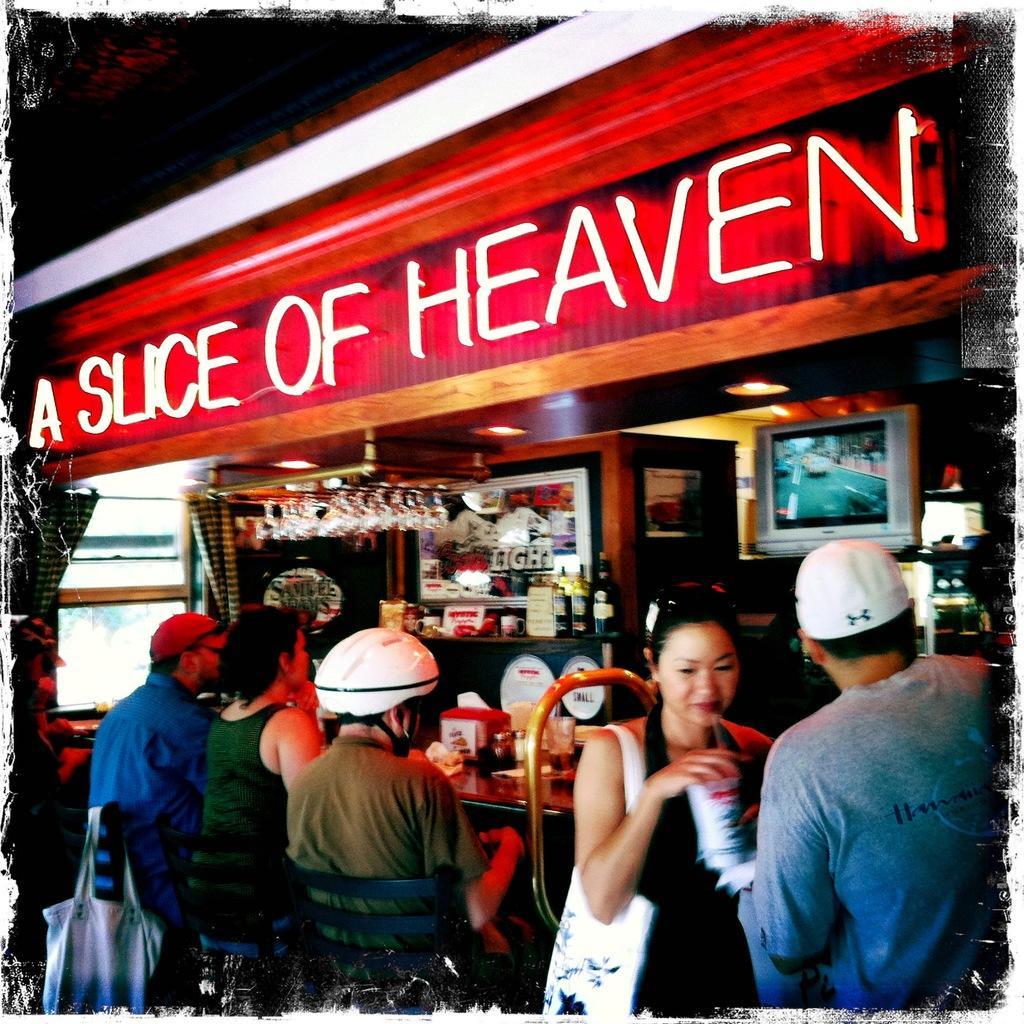Please provide a concise description of this image. In this image we can see many people. One person is wearing helmet. Two are wearing caps. One lady is holding a bag and a glass. And few are sitting on chairs. On the chair there is a bag. There is a shop. On the ship something is written. Also there is a TV. And there is a platform. On that there are bottles. Also there is a photo frame on the wall. And there are few other items in the shop. 